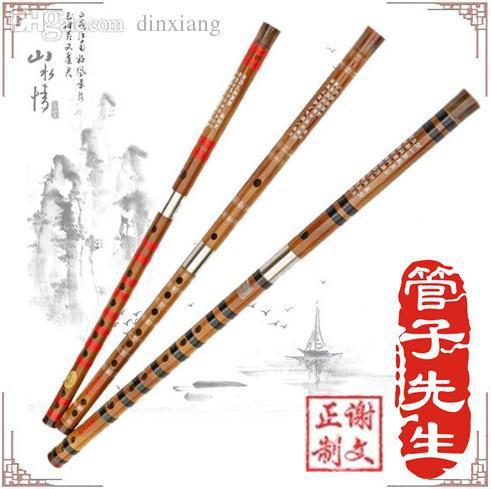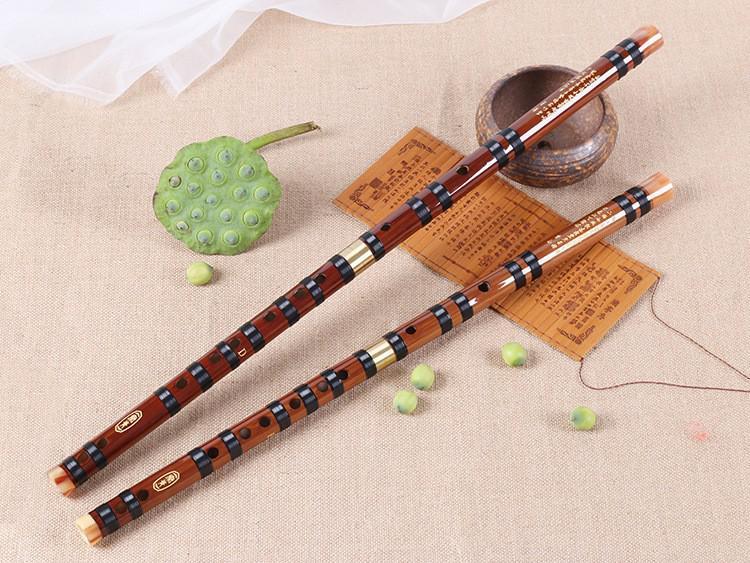The first image is the image on the left, the second image is the image on the right. Given the left and right images, does the statement "The left image has more flutes than the right image." hold true? Answer yes or no. Yes. The first image is the image on the left, the second image is the image on the right. For the images displayed, is the sentence "There are exactly five flutes." factually correct? Answer yes or no. Yes. 